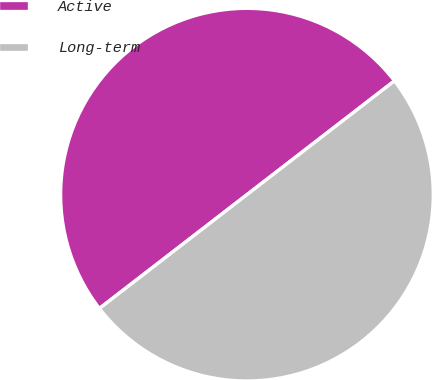<chart> <loc_0><loc_0><loc_500><loc_500><pie_chart><fcel>Active<fcel>Long-term<nl><fcel>50.0%<fcel>50.0%<nl></chart> 